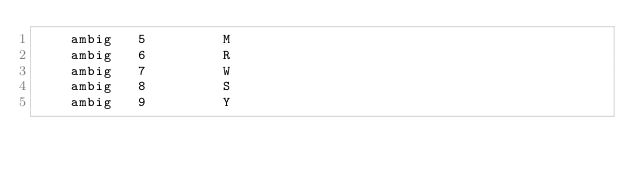Convert code to text. <code><loc_0><loc_0><loc_500><loc_500><_XML_>    ambig   5         M
    ambig   6         R
    ambig   7         W
    ambig   8         S
    ambig   9         Y</code> 